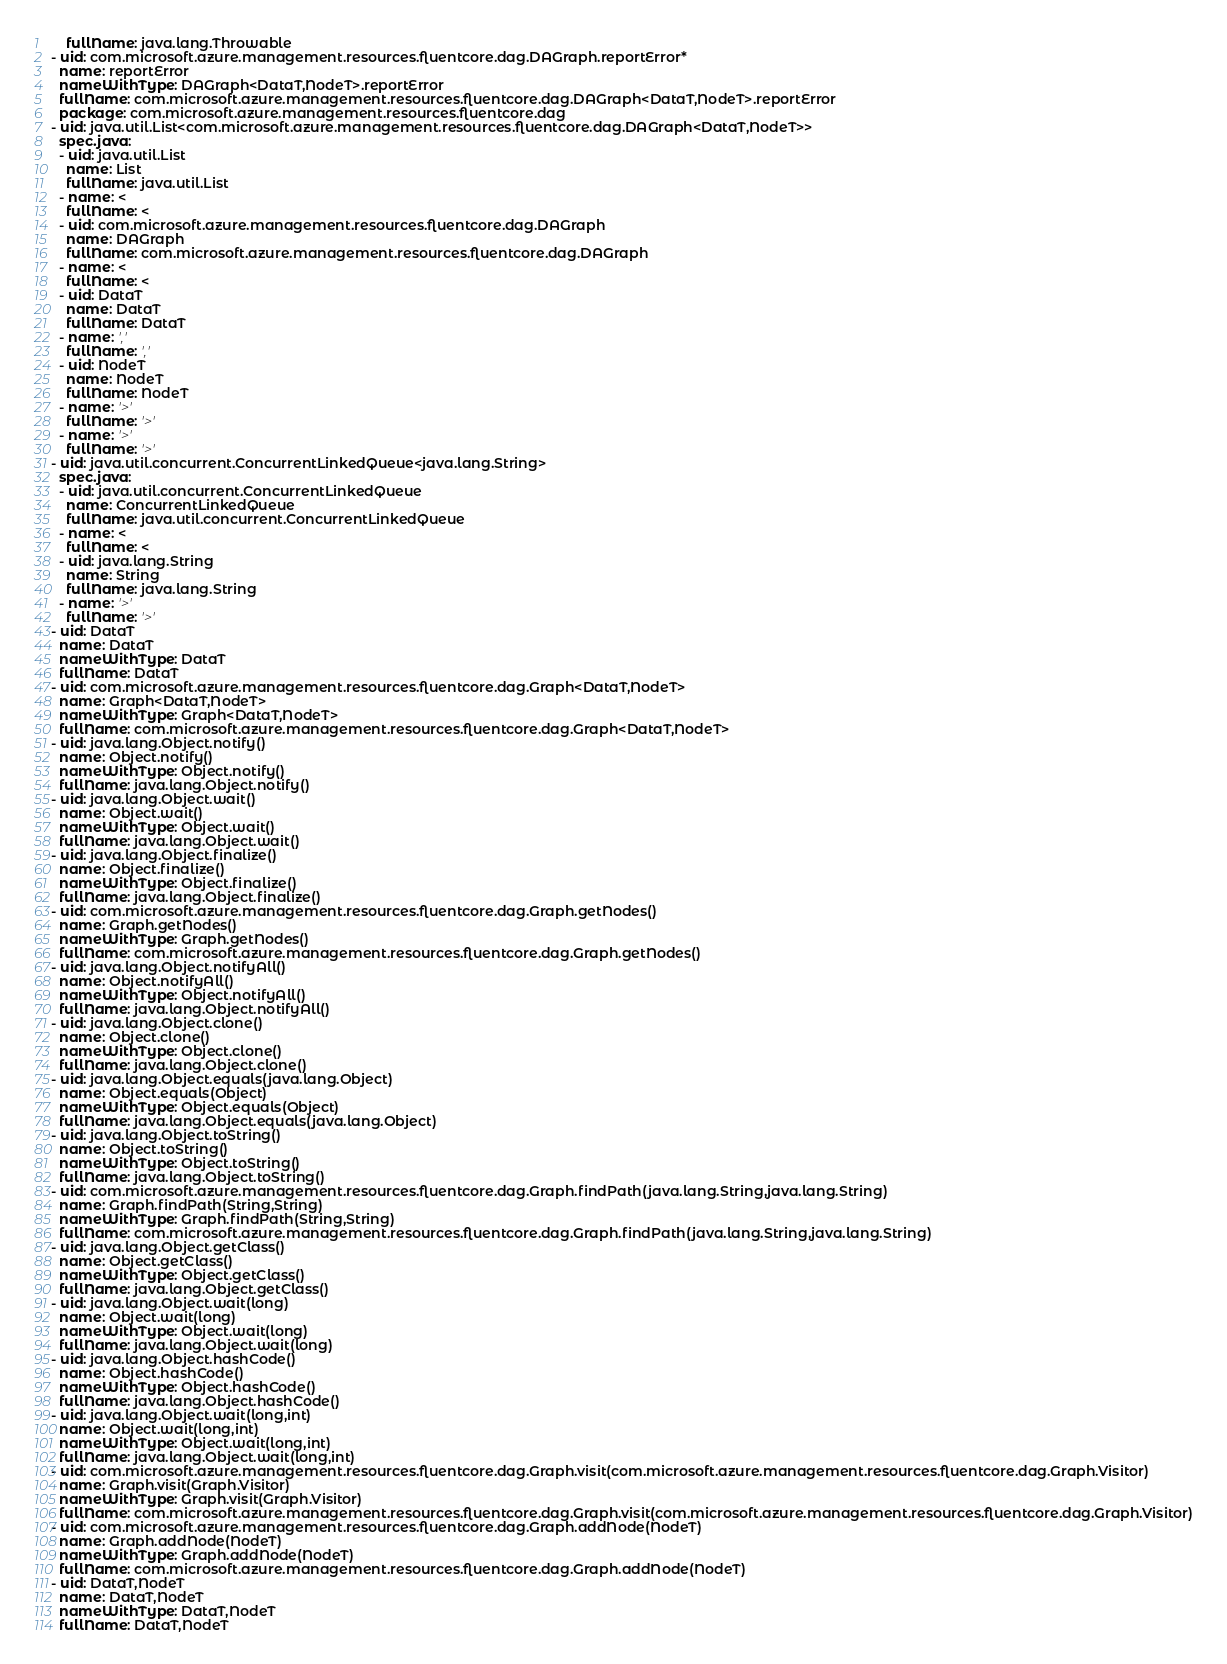<code> <loc_0><loc_0><loc_500><loc_500><_YAML_>    fullName: java.lang.Throwable
- uid: com.microsoft.azure.management.resources.fluentcore.dag.DAGraph.reportError*
  name: reportError
  nameWithType: DAGraph<DataT,NodeT>.reportError
  fullName: com.microsoft.azure.management.resources.fluentcore.dag.DAGraph<DataT,NodeT>.reportError
  package: com.microsoft.azure.management.resources.fluentcore.dag
- uid: java.util.List<com.microsoft.azure.management.resources.fluentcore.dag.DAGraph<DataT,NodeT>>
  spec.java:
  - uid: java.util.List
    name: List
    fullName: java.util.List
  - name: <
    fullName: <
  - uid: com.microsoft.azure.management.resources.fluentcore.dag.DAGraph
    name: DAGraph
    fullName: com.microsoft.azure.management.resources.fluentcore.dag.DAGraph
  - name: <
    fullName: <
  - uid: DataT
    name: DataT
    fullName: DataT
  - name: ','
    fullName: ','
  - uid: NodeT
    name: NodeT
    fullName: NodeT
  - name: '>'
    fullName: '>'
  - name: '>'
    fullName: '>'
- uid: java.util.concurrent.ConcurrentLinkedQueue<java.lang.String>
  spec.java:
  - uid: java.util.concurrent.ConcurrentLinkedQueue
    name: ConcurrentLinkedQueue
    fullName: java.util.concurrent.ConcurrentLinkedQueue
  - name: <
    fullName: <
  - uid: java.lang.String
    name: String
    fullName: java.lang.String
  - name: '>'
    fullName: '>'
- uid: DataT
  name: DataT
  nameWithType: DataT
  fullName: DataT
- uid: com.microsoft.azure.management.resources.fluentcore.dag.Graph<DataT,NodeT>
  name: Graph<DataT,NodeT>
  nameWithType: Graph<DataT,NodeT>
  fullName: com.microsoft.azure.management.resources.fluentcore.dag.Graph<DataT,NodeT>
- uid: java.lang.Object.notify()
  name: Object.notify()
  nameWithType: Object.notify()
  fullName: java.lang.Object.notify()
- uid: java.lang.Object.wait()
  name: Object.wait()
  nameWithType: Object.wait()
  fullName: java.lang.Object.wait()
- uid: java.lang.Object.finalize()
  name: Object.finalize()
  nameWithType: Object.finalize()
  fullName: java.lang.Object.finalize()
- uid: com.microsoft.azure.management.resources.fluentcore.dag.Graph.getNodes()
  name: Graph.getNodes()
  nameWithType: Graph.getNodes()
  fullName: com.microsoft.azure.management.resources.fluentcore.dag.Graph.getNodes()
- uid: java.lang.Object.notifyAll()
  name: Object.notifyAll()
  nameWithType: Object.notifyAll()
  fullName: java.lang.Object.notifyAll()
- uid: java.lang.Object.clone()
  name: Object.clone()
  nameWithType: Object.clone()
  fullName: java.lang.Object.clone()
- uid: java.lang.Object.equals(java.lang.Object)
  name: Object.equals(Object)
  nameWithType: Object.equals(Object)
  fullName: java.lang.Object.equals(java.lang.Object)
- uid: java.lang.Object.toString()
  name: Object.toString()
  nameWithType: Object.toString()
  fullName: java.lang.Object.toString()
- uid: com.microsoft.azure.management.resources.fluentcore.dag.Graph.findPath(java.lang.String,java.lang.String)
  name: Graph.findPath(String,String)
  nameWithType: Graph.findPath(String,String)
  fullName: com.microsoft.azure.management.resources.fluentcore.dag.Graph.findPath(java.lang.String,java.lang.String)
- uid: java.lang.Object.getClass()
  name: Object.getClass()
  nameWithType: Object.getClass()
  fullName: java.lang.Object.getClass()
- uid: java.lang.Object.wait(long)
  name: Object.wait(long)
  nameWithType: Object.wait(long)
  fullName: java.lang.Object.wait(long)
- uid: java.lang.Object.hashCode()
  name: Object.hashCode()
  nameWithType: Object.hashCode()
  fullName: java.lang.Object.hashCode()
- uid: java.lang.Object.wait(long,int)
  name: Object.wait(long,int)
  nameWithType: Object.wait(long,int)
  fullName: java.lang.Object.wait(long,int)
- uid: com.microsoft.azure.management.resources.fluentcore.dag.Graph.visit(com.microsoft.azure.management.resources.fluentcore.dag.Graph.Visitor)
  name: Graph.visit(Graph.Visitor)
  nameWithType: Graph.visit(Graph.Visitor)
  fullName: com.microsoft.azure.management.resources.fluentcore.dag.Graph.visit(com.microsoft.azure.management.resources.fluentcore.dag.Graph.Visitor)
- uid: com.microsoft.azure.management.resources.fluentcore.dag.Graph.addNode(NodeT)
  name: Graph.addNode(NodeT)
  nameWithType: Graph.addNode(NodeT)
  fullName: com.microsoft.azure.management.resources.fluentcore.dag.Graph.addNode(NodeT)
- uid: DataT,NodeT
  name: DataT,NodeT
  nameWithType: DataT,NodeT
  fullName: DataT,NodeT</code> 